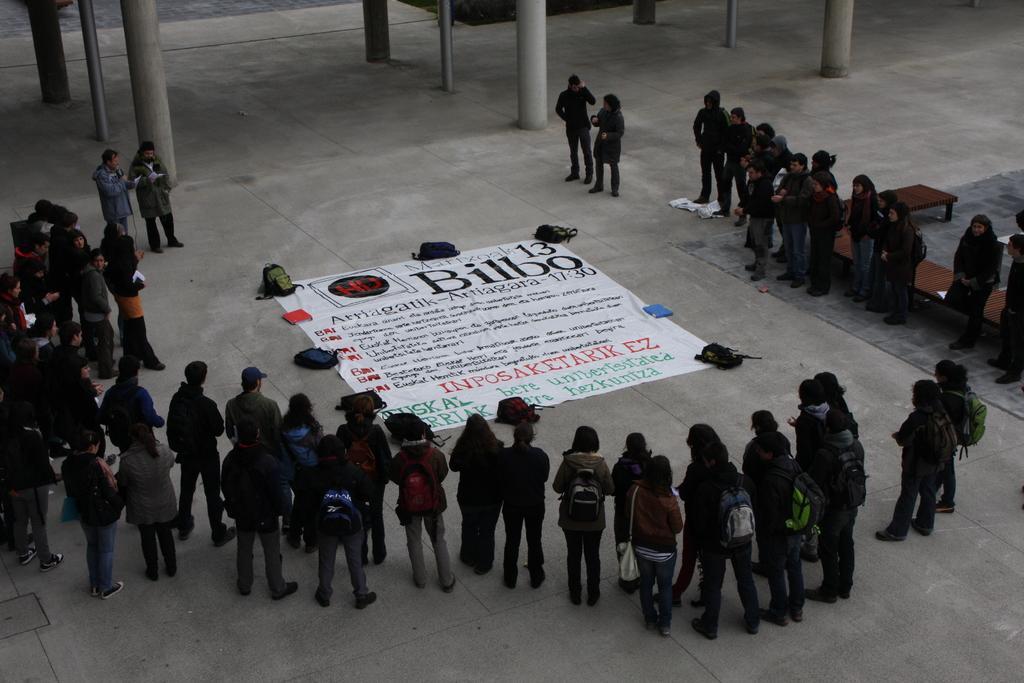Describe this image in one or two sentences. In this image we can see these people are standing here. Here we can see a banner on the floor and we can see backpacks are kept here. In the background, we can see the pillars. 